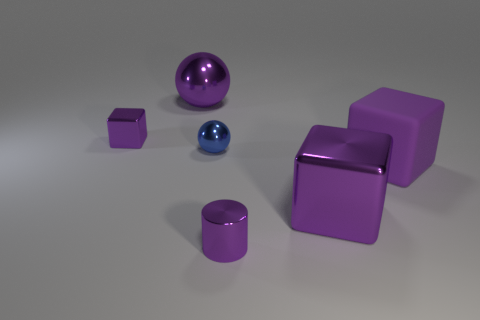Add 1 small red metal objects. How many objects exist? 7 Subtract all spheres. How many objects are left? 4 Add 6 green objects. How many green objects exist? 6 Subtract 0 brown blocks. How many objects are left? 6 Subtract all large yellow shiny cylinders. Subtract all purple metallic spheres. How many objects are left? 5 Add 2 big purple metal cubes. How many big purple metal cubes are left? 3 